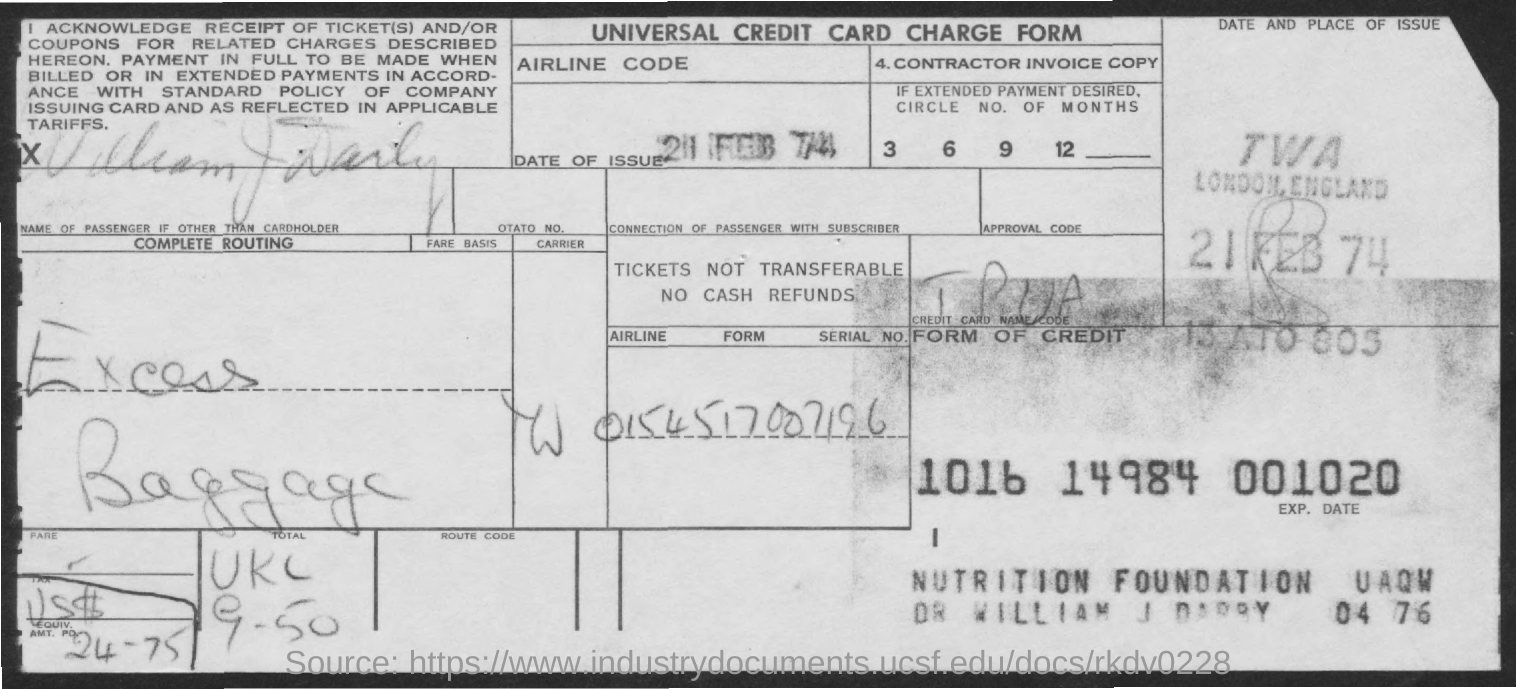List a handful of essential elements in this visual. The date of issue is February 21, 1974. This universal credit card charge form is about a specific financial transaction. 